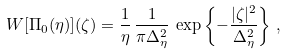<formula> <loc_0><loc_0><loc_500><loc_500>W [ \Pi _ { 0 } ( \eta ) ] ( \zeta ) = \frac { 1 } { \eta } \, \frac { 1 } { \pi \Delta _ { \eta } ^ { 2 } } \, \exp \left \{ - \frac { | \zeta | ^ { 2 } } { \Delta _ { \eta } ^ { 2 } } \right \} \, ,</formula> 